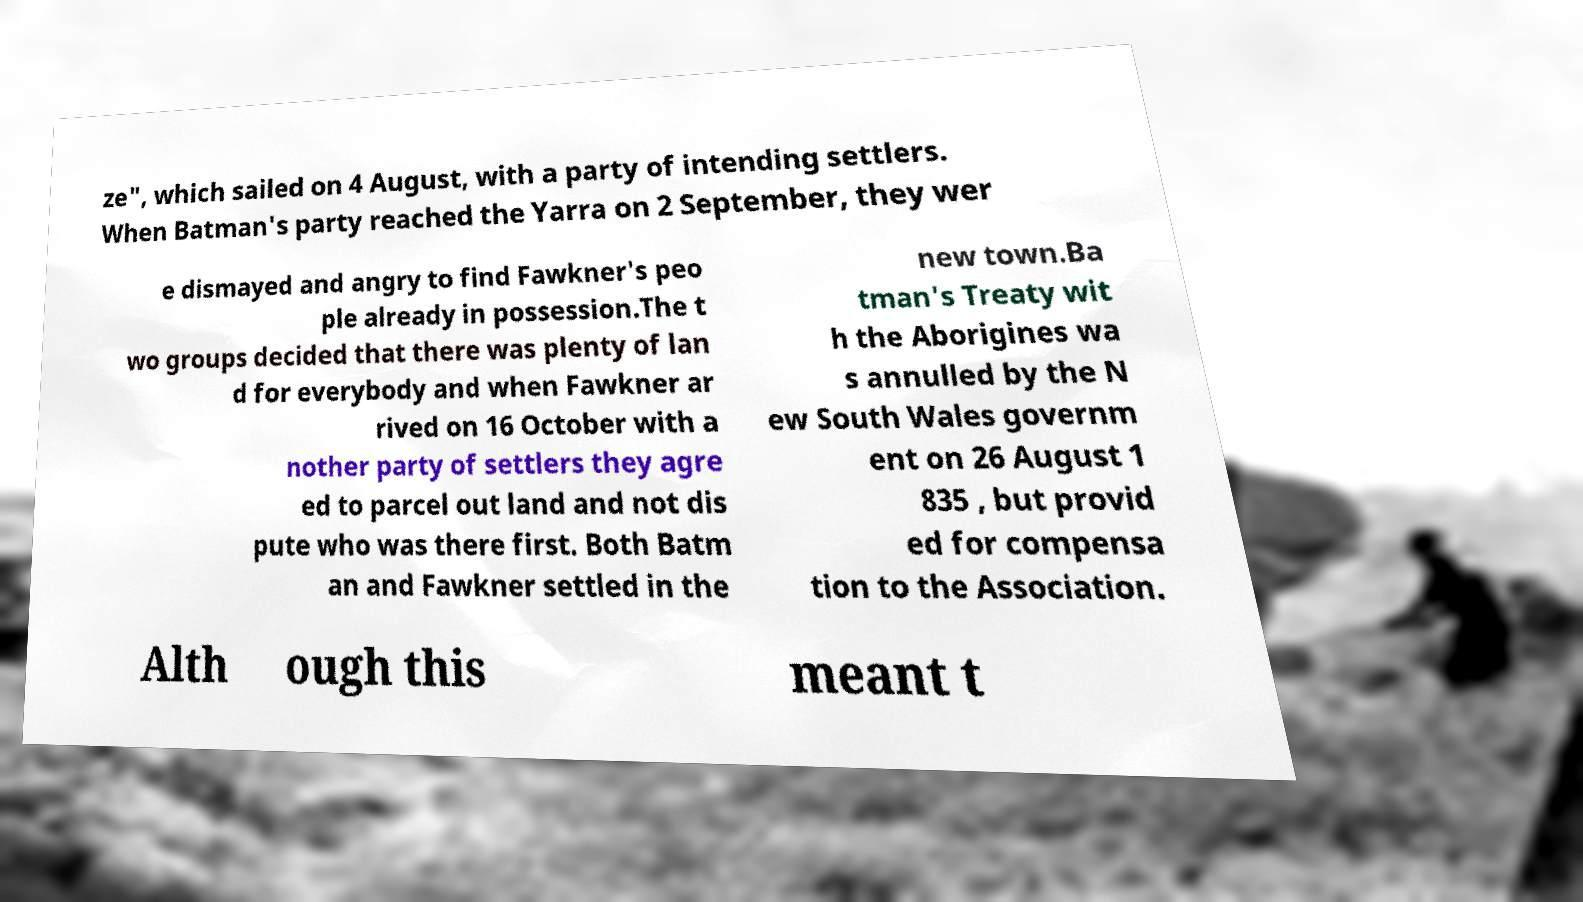Can you accurately transcribe the text from the provided image for me? ze", which sailed on 4 August, with a party of intending settlers. When Batman's party reached the Yarra on 2 September, they wer e dismayed and angry to find Fawkner's peo ple already in possession.The t wo groups decided that there was plenty of lan d for everybody and when Fawkner ar rived on 16 October with a nother party of settlers they agre ed to parcel out land and not dis pute who was there first. Both Batm an and Fawkner settled in the new town.Ba tman's Treaty wit h the Aborigines wa s annulled by the N ew South Wales governm ent on 26 August 1 835 , but provid ed for compensa tion to the Association. Alth ough this meant t 